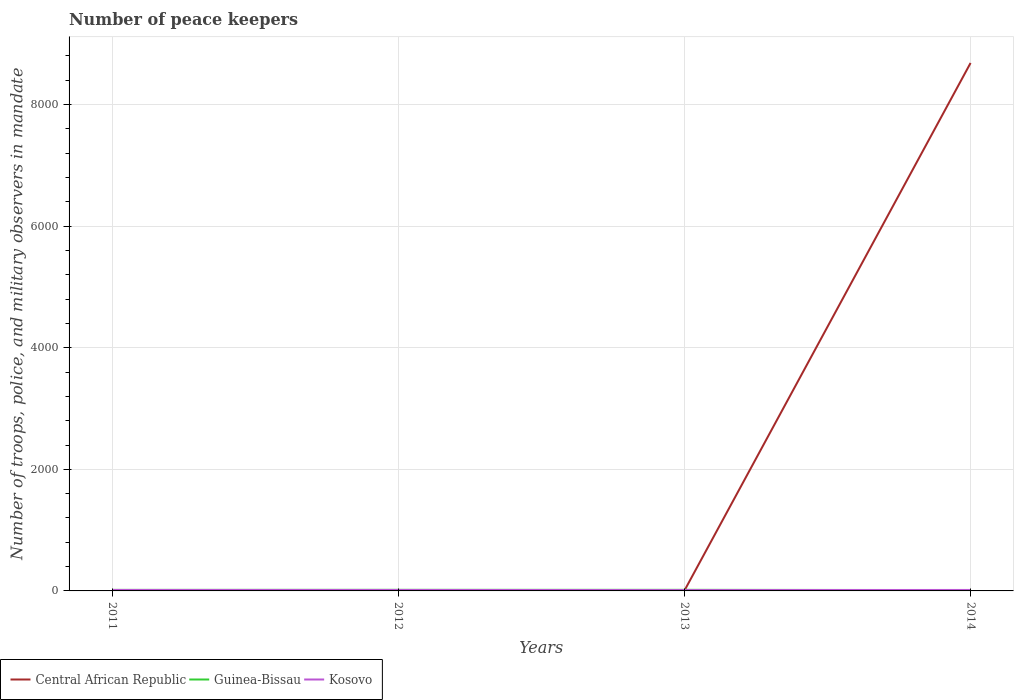How many different coloured lines are there?
Provide a short and direct response. 3. Does the line corresponding to Central African Republic intersect with the line corresponding to Kosovo?
Provide a short and direct response. Yes. Is the number of lines equal to the number of legend labels?
Provide a short and direct response. Yes. Across all years, what is the maximum number of peace keepers in in Kosovo?
Make the answer very short. 14. What is the total number of peace keepers in in Central African Republic in the graph?
Offer a terse response. -8681. Is the number of peace keepers in in Guinea-Bissau strictly greater than the number of peace keepers in in Central African Republic over the years?
Offer a very short reply. No. How many lines are there?
Ensure brevity in your answer.  3. How many years are there in the graph?
Provide a short and direct response. 4. How many legend labels are there?
Give a very brief answer. 3. What is the title of the graph?
Your answer should be very brief. Number of peace keepers. Does "Slovak Republic" appear as one of the legend labels in the graph?
Make the answer very short. No. What is the label or title of the X-axis?
Your response must be concise. Years. What is the label or title of the Y-axis?
Your answer should be very brief. Number of troops, police, and military observers in mandate. What is the Number of troops, police, and military observers in mandate of Central African Republic in 2011?
Ensure brevity in your answer.  4. What is the Number of troops, police, and military observers in mandate of Guinea-Bissau in 2011?
Offer a terse response. 17. What is the Number of troops, police, and military observers in mandate of Kosovo in 2011?
Provide a short and direct response. 16. What is the Number of troops, police, and military observers in mandate in Central African Republic in 2012?
Offer a very short reply. 4. What is the Number of troops, police, and military observers in mandate in Guinea-Bissau in 2012?
Make the answer very short. 18. What is the Number of troops, police, and military observers in mandate in Guinea-Bissau in 2013?
Make the answer very short. 18. What is the Number of troops, police, and military observers in mandate of Kosovo in 2013?
Provide a succinct answer. 14. What is the Number of troops, police, and military observers in mandate in Central African Republic in 2014?
Keep it short and to the point. 8685. What is the Number of troops, police, and military observers in mandate in Guinea-Bissau in 2014?
Provide a short and direct response. 14. What is the Number of troops, police, and military observers in mandate of Kosovo in 2014?
Make the answer very short. 16. Across all years, what is the maximum Number of troops, police, and military observers in mandate in Central African Republic?
Offer a terse response. 8685. Across all years, what is the maximum Number of troops, police, and military observers in mandate in Guinea-Bissau?
Provide a succinct answer. 18. Across all years, what is the minimum Number of troops, police, and military observers in mandate of Central African Republic?
Provide a succinct answer. 4. Across all years, what is the minimum Number of troops, police, and military observers in mandate in Kosovo?
Offer a terse response. 14. What is the total Number of troops, police, and military observers in mandate of Central African Republic in the graph?
Make the answer very short. 8697. What is the total Number of troops, police, and military observers in mandate of Guinea-Bissau in the graph?
Keep it short and to the point. 67. What is the difference between the Number of troops, police, and military observers in mandate of Central African Republic in 2011 and that in 2012?
Offer a very short reply. 0. What is the difference between the Number of troops, police, and military observers in mandate of Kosovo in 2011 and that in 2012?
Give a very brief answer. 0. What is the difference between the Number of troops, police, and military observers in mandate in Central African Republic in 2011 and that in 2014?
Give a very brief answer. -8681. What is the difference between the Number of troops, police, and military observers in mandate of Guinea-Bissau in 2011 and that in 2014?
Offer a very short reply. 3. What is the difference between the Number of troops, police, and military observers in mandate in Kosovo in 2011 and that in 2014?
Your answer should be compact. 0. What is the difference between the Number of troops, police, and military observers in mandate of Central African Republic in 2012 and that in 2014?
Offer a terse response. -8681. What is the difference between the Number of troops, police, and military observers in mandate in Kosovo in 2012 and that in 2014?
Offer a very short reply. 0. What is the difference between the Number of troops, police, and military observers in mandate of Central African Republic in 2013 and that in 2014?
Your answer should be very brief. -8681. What is the difference between the Number of troops, police, and military observers in mandate of Central African Republic in 2011 and the Number of troops, police, and military observers in mandate of Guinea-Bissau in 2012?
Provide a succinct answer. -14. What is the difference between the Number of troops, police, and military observers in mandate in Guinea-Bissau in 2011 and the Number of troops, police, and military observers in mandate in Kosovo in 2012?
Ensure brevity in your answer.  1. What is the difference between the Number of troops, police, and military observers in mandate in Central African Republic in 2011 and the Number of troops, police, and military observers in mandate in Guinea-Bissau in 2013?
Provide a short and direct response. -14. What is the difference between the Number of troops, police, and military observers in mandate of Central African Republic in 2011 and the Number of troops, police, and military observers in mandate of Kosovo in 2013?
Your response must be concise. -10. What is the difference between the Number of troops, police, and military observers in mandate of Central African Republic in 2012 and the Number of troops, police, and military observers in mandate of Guinea-Bissau in 2013?
Give a very brief answer. -14. What is the difference between the Number of troops, police, and military observers in mandate in Guinea-Bissau in 2012 and the Number of troops, police, and military observers in mandate in Kosovo in 2013?
Your answer should be compact. 4. What is the difference between the Number of troops, police, and military observers in mandate in Central African Republic in 2012 and the Number of troops, police, and military observers in mandate in Kosovo in 2014?
Offer a terse response. -12. What is the difference between the Number of troops, police, and military observers in mandate in Guinea-Bissau in 2012 and the Number of troops, police, and military observers in mandate in Kosovo in 2014?
Your response must be concise. 2. What is the difference between the Number of troops, police, and military observers in mandate in Central African Republic in 2013 and the Number of troops, police, and military observers in mandate in Kosovo in 2014?
Give a very brief answer. -12. What is the difference between the Number of troops, police, and military observers in mandate in Guinea-Bissau in 2013 and the Number of troops, police, and military observers in mandate in Kosovo in 2014?
Keep it short and to the point. 2. What is the average Number of troops, police, and military observers in mandate in Central African Republic per year?
Keep it short and to the point. 2174.25. What is the average Number of troops, police, and military observers in mandate of Guinea-Bissau per year?
Offer a very short reply. 16.75. What is the average Number of troops, police, and military observers in mandate in Kosovo per year?
Provide a succinct answer. 15.5. In the year 2012, what is the difference between the Number of troops, police, and military observers in mandate in Central African Republic and Number of troops, police, and military observers in mandate in Guinea-Bissau?
Offer a very short reply. -14. In the year 2013, what is the difference between the Number of troops, police, and military observers in mandate of Central African Republic and Number of troops, police, and military observers in mandate of Kosovo?
Provide a succinct answer. -10. In the year 2014, what is the difference between the Number of troops, police, and military observers in mandate of Central African Republic and Number of troops, police, and military observers in mandate of Guinea-Bissau?
Your response must be concise. 8671. In the year 2014, what is the difference between the Number of troops, police, and military observers in mandate of Central African Republic and Number of troops, police, and military observers in mandate of Kosovo?
Make the answer very short. 8669. What is the ratio of the Number of troops, police, and military observers in mandate of Guinea-Bissau in 2011 to that in 2012?
Offer a terse response. 0.94. What is the ratio of the Number of troops, police, and military observers in mandate in Kosovo in 2011 to that in 2012?
Provide a succinct answer. 1. What is the ratio of the Number of troops, police, and military observers in mandate of Central African Republic in 2011 to that in 2013?
Make the answer very short. 1. What is the ratio of the Number of troops, police, and military observers in mandate in Central African Republic in 2011 to that in 2014?
Give a very brief answer. 0. What is the ratio of the Number of troops, police, and military observers in mandate of Guinea-Bissau in 2011 to that in 2014?
Ensure brevity in your answer.  1.21. What is the ratio of the Number of troops, police, and military observers in mandate of Kosovo in 2012 to that in 2013?
Offer a very short reply. 1.14. What is the ratio of the Number of troops, police, and military observers in mandate of Central African Republic in 2012 to that in 2014?
Provide a succinct answer. 0. What is the ratio of the Number of troops, police, and military observers in mandate in Central African Republic in 2013 to that in 2014?
Your response must be concise. 0. What is the difference between the highest and the second highest Number of troops, police, and military observers in mandate in Central African Republic?
Your answer should be compact. 8681. What is the difference between the highest and the lowest Number of troops, police, and military observers in mandate in Central African Republic?
Ensure brevity in your answer.  8681. What is the difference between the highest and the lowest Number of troops, police, and military observers in mandate in Guinea-Bissau?
Your answer should be very brief. 4. 